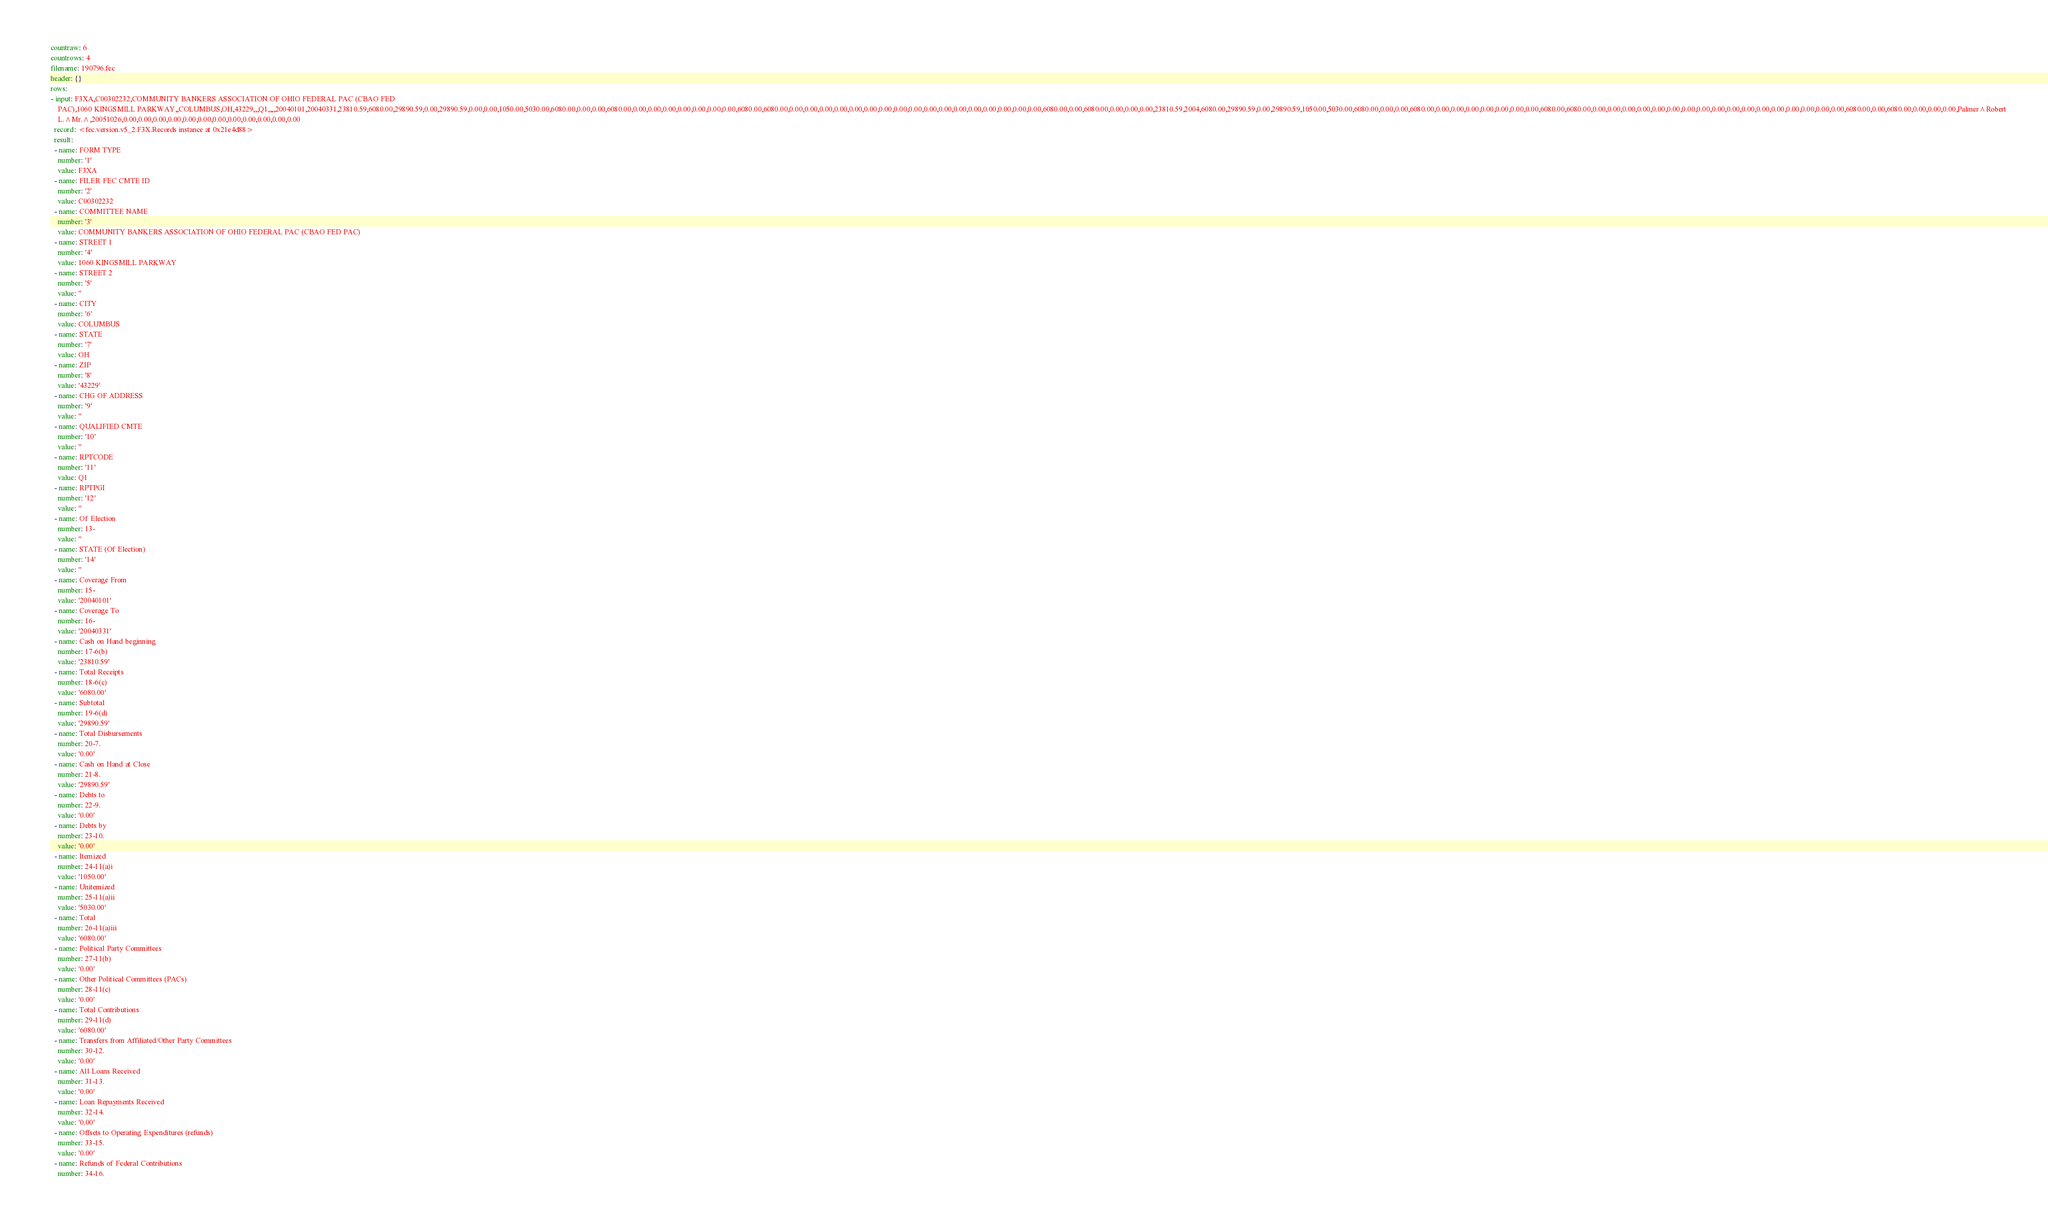Convert code to text. <code><loc_0><loc_0><loc_500><loc_500><_YAML_>countraw: 6
countrows: 4
filename: 190796.fec
header: {}
rows:
- input: F3XA,C00302232,COMMUNITY BANKERS ASSOCIATION OF OHIO FEDERAL PAC (CBAO FED
    PAC),1060 KINGSMILL PARKWAY,,COLUMBUS,OH,43229,,,Q1,,,,20040101,20040331,23810.59,6080.00,29890.59,0.00,29890.59,0.00,0.00,1050.00,5030.00,6080.00,0.00,0.00,6080.00,0.00,0.00,0.00,0.00,0.00,0.00,0.00,6080.00,6080.00,0.00,0.00,0.00,0.00,0.00,0.00,0.00,0.00,0.00,0.00,0.00,0.00,0.00,0.00,0.00,0.00,0.00,6080.00,0.00,6080.00,0.00,0.00,0.00,23810.59,2004,6080.00,29890.59,0.00,29890.59,1050.00,5030.00,6080.00,0.00,0.00,6080.00,0.00,0.00,0.00,0.00,0.00,0.00,0.00,6080.00,6080.00,0.00,0.00,0.00,0.00,0.00,0.00,0.00,0.00,0.00,0.00,0.00,0.00,0.00,0.00,0.00,0.00,0.00,6080.00,0.00,6080.00,0.00,0.00,0.00,Palmer^Robert
    L.^Mr.^,20051026,0.00,0.00,0.00,0.00,0.00,0.00,0.00,0.00,0.00,0.00,0.00,0.00
  record: <fec.version.v5_2.F3X.Records instance at 0x21e4d88>
  result:
  - name: FORM TYPE
    number: '1'
    value: F3XA
  - name: FILER FEC CMTE ID
    number: '2'
    value: C00302232
  - name: COMMITTEE NAME
    number: '3'
    value: COMMUNITY BANKERS ASSOCIATION OF OHIO FEDERAL PAC (CBAO FED PAC)
  - name: STREET 1
    number: '4'
    value: 1060 KINGSMILL PARKWAY
  - name: STREET 2
    number: '5'
    value: ''
  - name: CITY
    number: '6'
    value: COLUMBUS
  - name: STATE
    number: '7'
    value: OH
  - name: ZIP
    number: '8'
    value: '43229'
  - name: CHG OF ADDRESS
    number: '9'
    value: ''
  - name: QUALIFIED CMTE
    number: '10'
    value: ''
  - name: RPTCODE
    number: '11'
    value: Q1
  - name: RPTPGI
    number: '12'
    value: ''
  - name: Of Election
    number: 13-
    value: ''
  - name: STATE (Of Election)
    number: '14'
    value: ''
  - name: Coverage From
    number: 15-
    value: '20040101'
  - name: Coverage To
    number: 16-
    value: '20040331'
  - name: Cash on Hand beginning
    number: 17-6(b)
    value: '23810.59'
  - name: Total Receipts
    number: 18-6(c)
    value: '6080.00'
  - name: Subtotal
    number: 19-6(d)
    value: '29890.59'
  - name: Total Disbursements
    number: 20-7.
    value: '0.00'
  - name: Cash on Hand at Close
    number: 21-8.
    value: '29890.59'
  - name: Debts to
    number: 22-9.
    value: '0.00'
  - name: Debts by
    number: 23-10.
    value: '0.00'
  - name: Itemized
    number: 24-11(a)i
    value: '1050.00'
  - name: Unitemized
    number: 25-11(a)ii
    value: '5030.00'
  - name: Total
    number: 26-11(a)iii
    value: '6080.00'
  - name: Political Party Committees
    number: 27-11(b)
    value: '0.00'
  - name: Other Political Committees (PACs)
    number: 28-11(c)
    value: '0.00'
  - name: Total Contributions
    number: 29-11(d)
    value: '6080.00'
  - name: Transfers from Affiliated/Other Party Committees
    number: 30-12.
    value: '0.00'
  - name: All Loans Received
    number: 31-13.
    value: '0.00'
  - name: Loan Repayments Received
    number: 32-14.
    value: '0.00'
  - name: Offsets to Operating Expenditures (refunds)
    number: 33-15.
    value: '0.00'
  - name: Refunds of Federal Contributions
    number: 34-16.</code> 